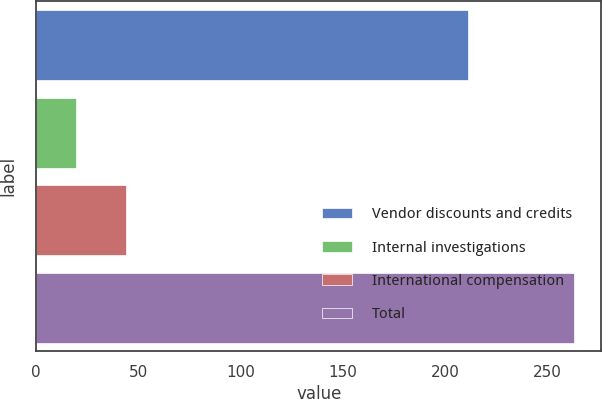Convert chart. <chart><loc_0><loc_0><loc_500><loc_500><bar_chart><fcel>Vendor discounts and credits<fcel>Internal investigations<fcel>International compensation<fcel>Total<nl><fcel>211.2<fcel>19.5<fcel>43.85<fcel>263<nl></chart> 